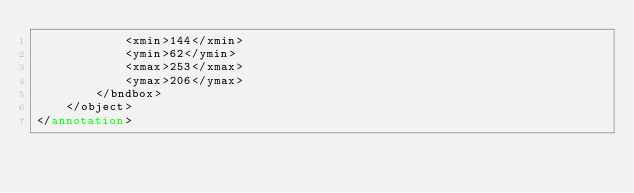Convert code to text. <code><loc_0><loc_0><loc_500><loc_500><_XML_>			<xmin>144</xmin>
			<ymin>62</ymin>
			<xmax>253</xmax>
			<ymax>206</ymax>
		</bndbox>
	</object>
</annotation>
</code> 